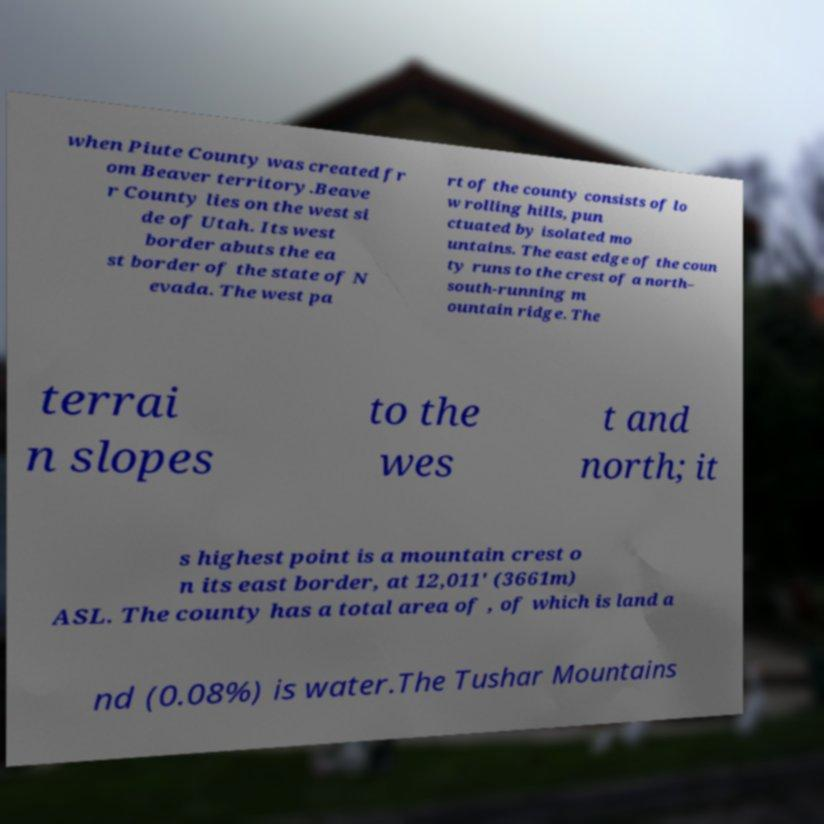Can you read and provide the text displayed in the image?This photo seems to have some interesting text. Can you extract and type it out for me? when Piute County was created fr om Beaver territory.Beave r County lies on the west si de of Utah. Its west border abuts the ea st border of the state of N evada. The west pa rt of the county consists of lo w rolling hills, pun ctuated by isolated mo untains. The east edge of the coun ty runs to the crest of a north– south-running m ountain ridge. The terrai n slopes to the wes t and north; it s highest point is a mountain crest o n its east border, at 12,011' (3661m) ASL. The county has a total area of , of which is land a nd (0.08%) is water.The Tushar Mountains 